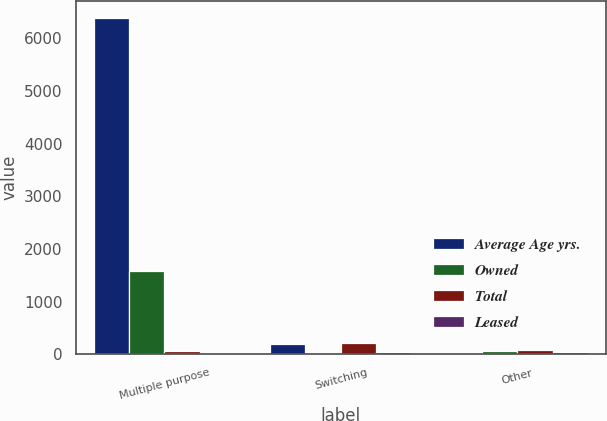Convert chart. <chart><loc_0><loc_0><loc_500><loc_500><stacked_bar_chart><ecel><fcel>Multiple purpose<fcel>Switching<fcel>Other<nl><fcel>Average Age yrs.<fcel>6387<fcel>201<fcel>35<nl><fcel>Owned<fcel>1582<fcel>12<fcel>57<nl><fcel>Total<fcel>57<fcel>213<fcel>92<nl><fcel>Leased<fcel>20.5<fcel>38.3<fcel>39.6<nl></chart> 